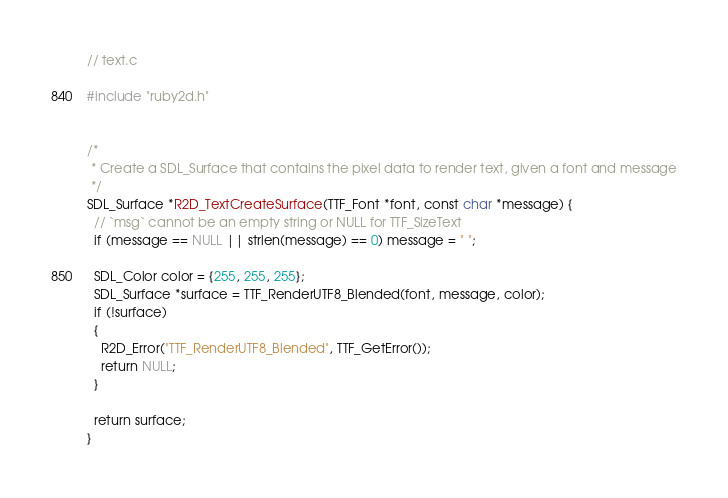Convert code to text. <code><loc_0><loc_0><loc_500><loc_500><_C_>// text.c

#include "ruby2d.h"


/*
 * Create a SDL_Surface that contains the pixel data to render text, given a font and message
 */
SDL_Surface *R2D_TextCreateSurface(TTF_Font *font, const char *message) {
  // `msg` cannot be an empty string or NULL for TTF_SizeText
  if (message == NULL || strlen(message) == 0) message = " ";

  SDL_Color color = {255, 255, 255};
  SDL_Surface *surface = TTF_RenderUTF8_Blended(font, message, color);
  if (!surface)
  {
    R2D_Error("TTF_RenderUTF8_Blended", TTF_GetError());
    return NULL;
  }

  return surface;
}</code> 